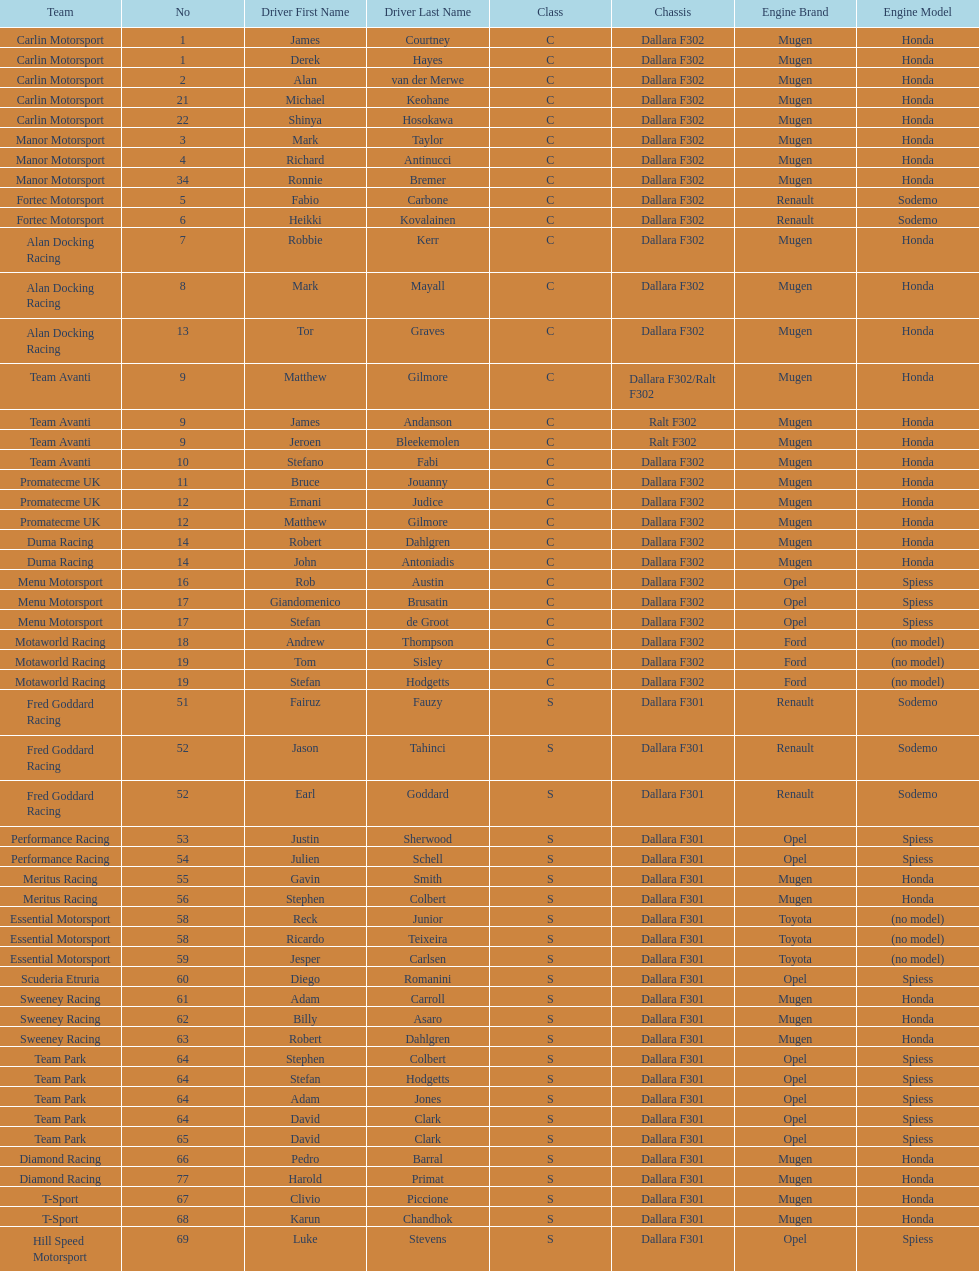The two drivers on t-sport are clivio piccione and what other driver? Karun Chandhok. 